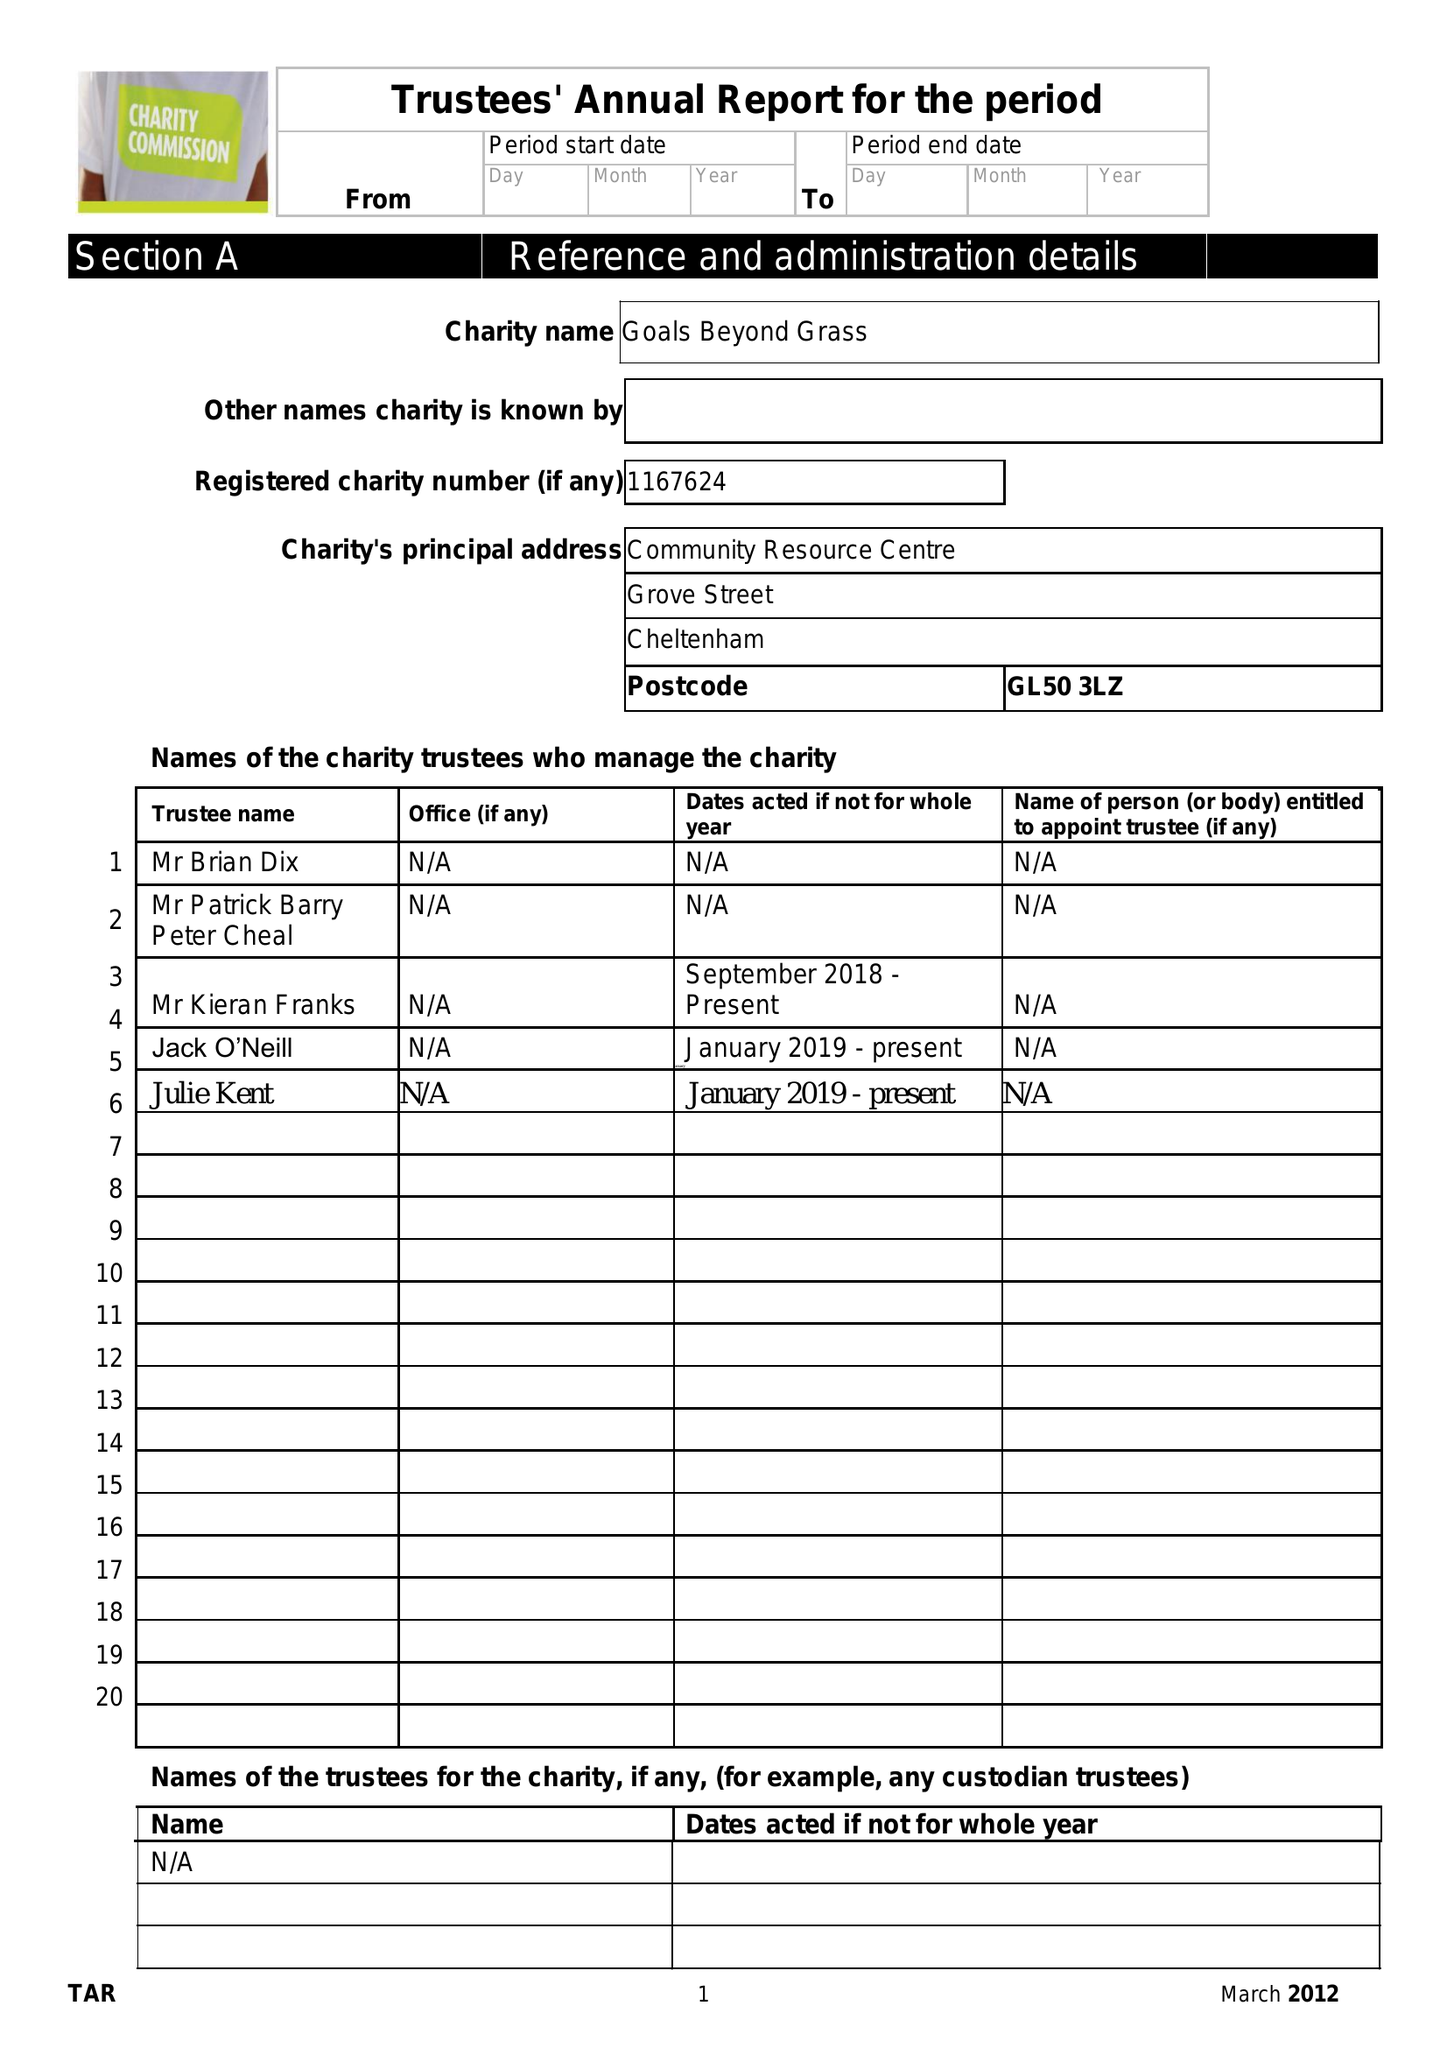What is the value for the spending_annually_in_british_pounds?
Answer the question using a single word or phrase. 100710.00 